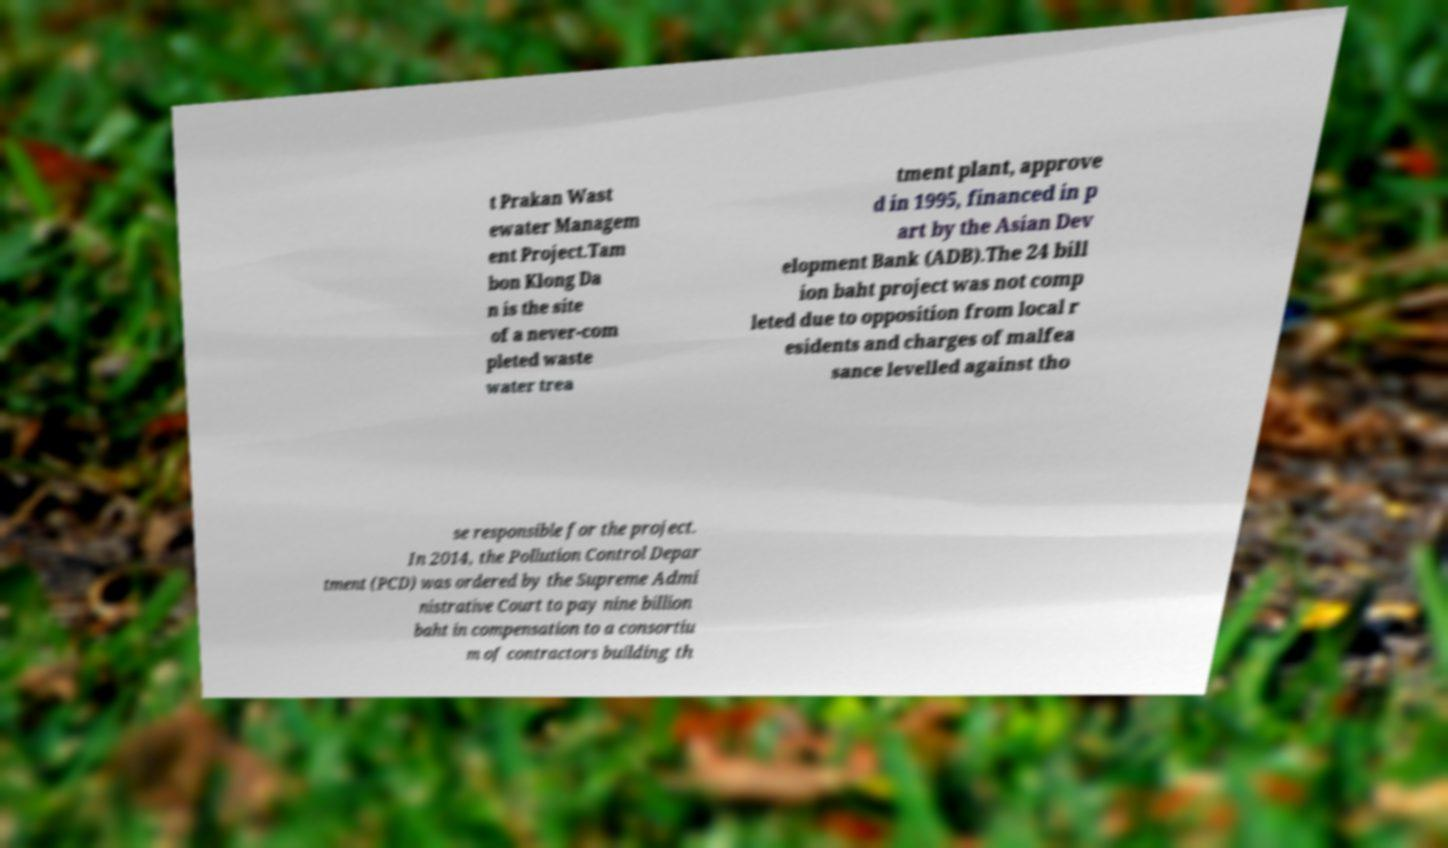Please identify and transcribe the text found in this image. t Prakan Wast ewater Managem ent Project.Tam bon Klong Da n is the site of a never-com pleted waste water trea tment plant, approve d in 1995, financed in p art by the Asian Dev elopment Bank (ADB).The 24 bill ion baht project was not comp leted due to opposition from local r esidents and charges of malfea sance levelled against tho se responsible for the project. In 2014, the Pollution Control Depar tment (PCD) was ordered by the Supreme Admi nistrative Court to pay nine billion baht in compensation to a consortiu m of contractors building th 